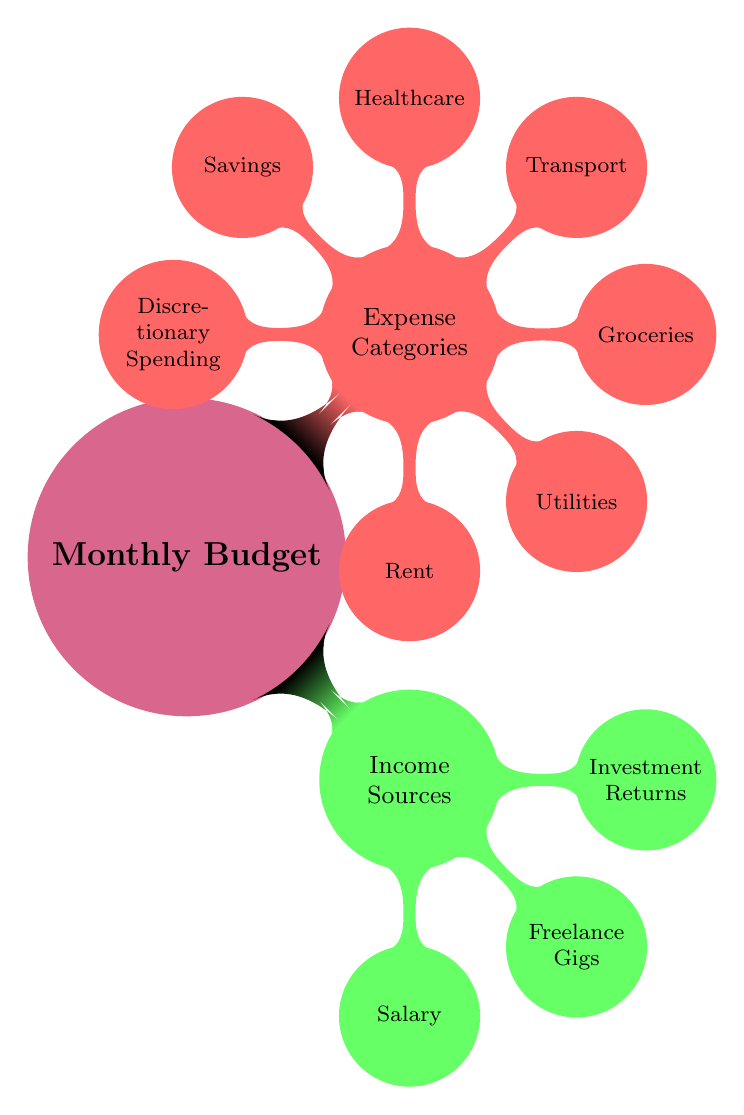What are the main categories of the monthly budget? The diagram shows two main categories under the Monthly Budget: Income Sources and Expense Categories.
Answer: Income Sources and Expense Categories How many income sources are listed in the diagram? The diagram lists three income sources: Salary, Freelance Gigs, and Investment Returns. Therefore, the total is three.
Answer: Three Which expense category is related to housing costs? The Rent is specifically mentioned under the Expense Categories as the expense related to housing costs.
Answer: Rent What is the relationship between Income Sources and Expense Categories? Income Sources and Expense Categories are two primary components of the Monthly Budget. Income Sources represent where the money comes from, while Expense Categories indicate where the money is spent.
Answer: Components of Monthly Budget Which category has the highest number of elements? The Expense Categories have a total of seven elements, while the Income Sources have three. Therefore, Expense Categories have more elements.
Answer: Expense Categories Which expense category is associated with savings? The Savings category is explicitly mentioned under Expense Categories, indicating it is related to saving money.
Answer: Savings How many different types of expenses are represented in the diagram? The diagram outlines six different types of expenses, which include Rent, Utilities, Groceries, Transport, Healthcare, and Discretionary Spending.
Answer: Six Which two types of income generation methods are mentioned? The diagram mentions Salary and Freelance Gigs as two types of income generation methods.
Answer: Salary and Freelance Gigs If you combine the two categories of the budget, how many total items are there? There are a total of three Income Sources and six Expense Categories, totaling nine items when both categories are combined.
Answer: Nine 